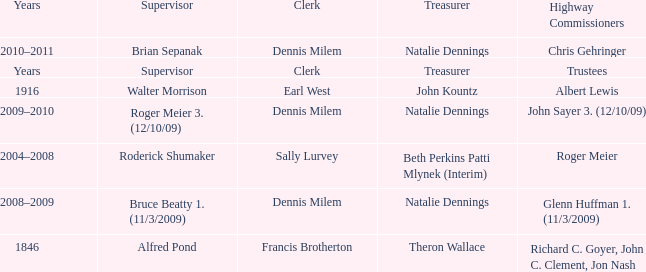Who was the clerk when the highway commissioner was Albert Lewis? Earl West. 